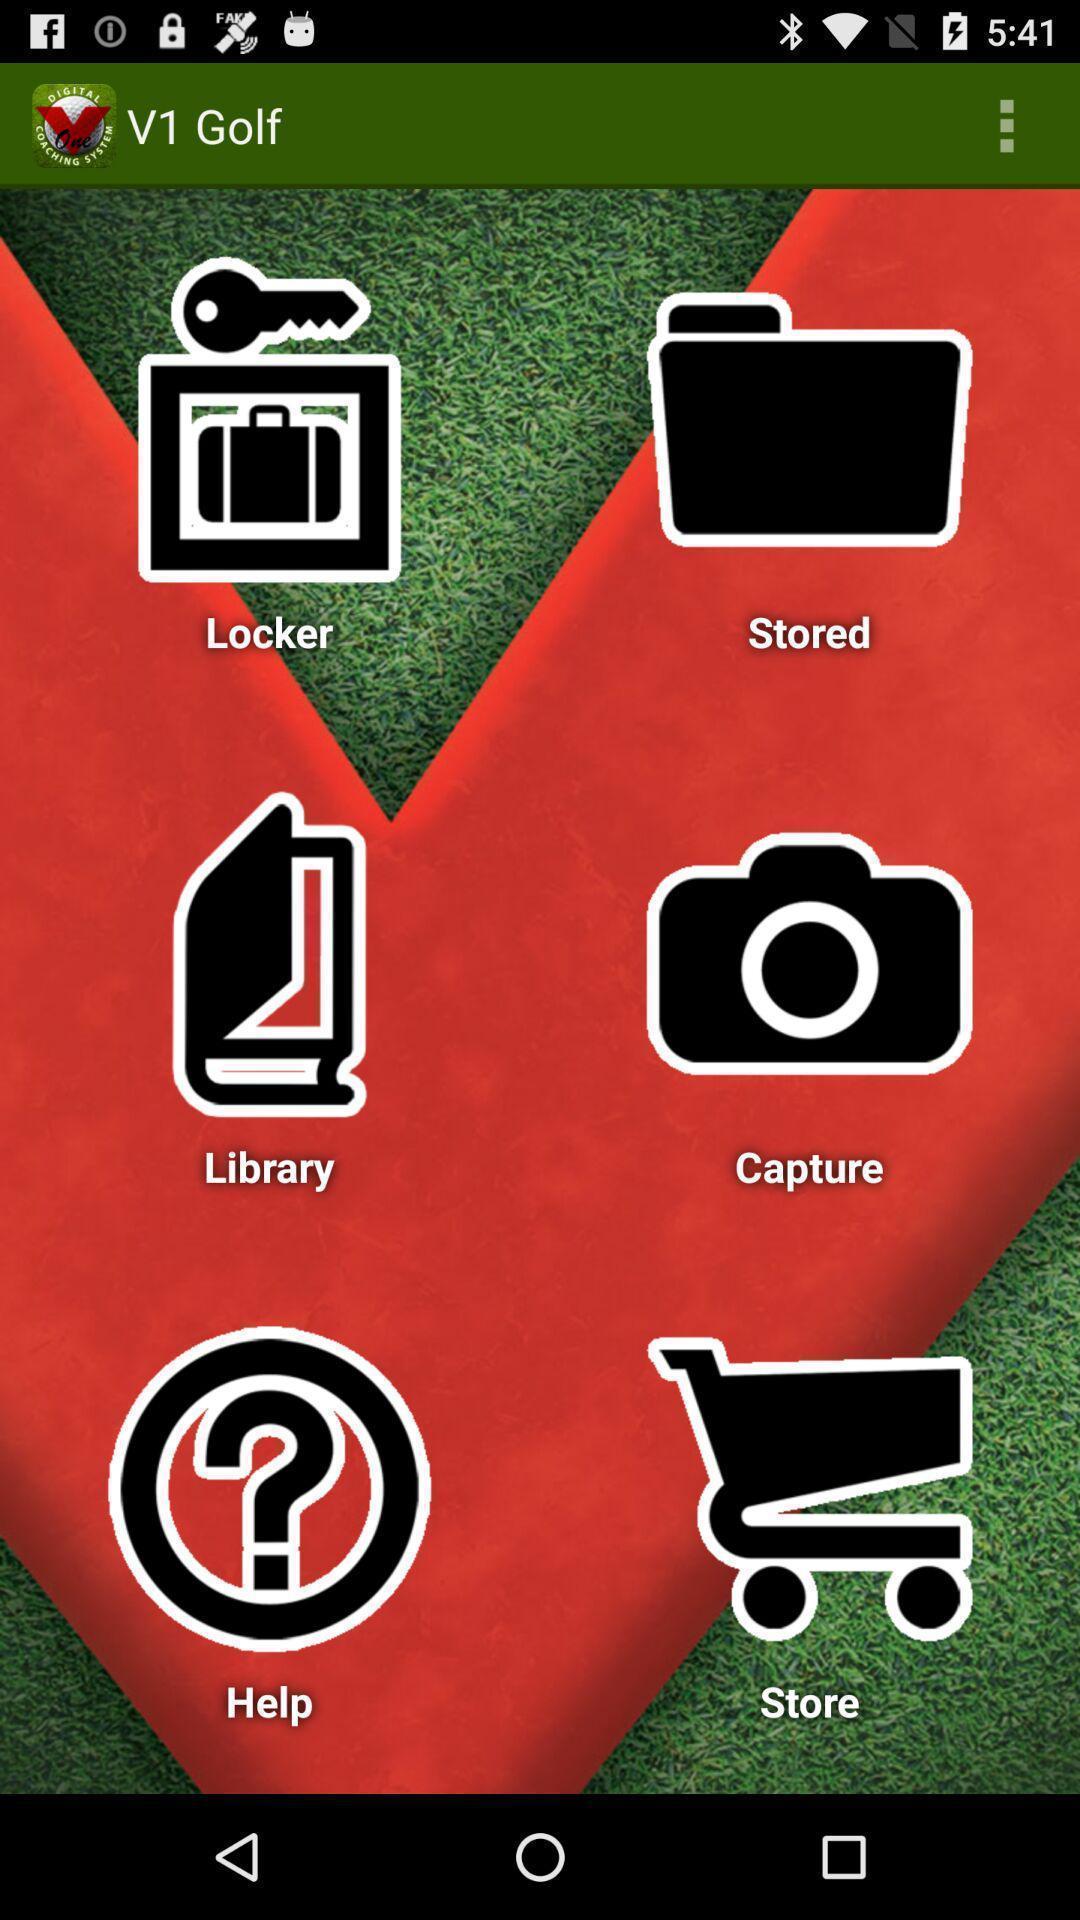Describe the key features of this screenshot. Page displaying the different types of v1 golf. 